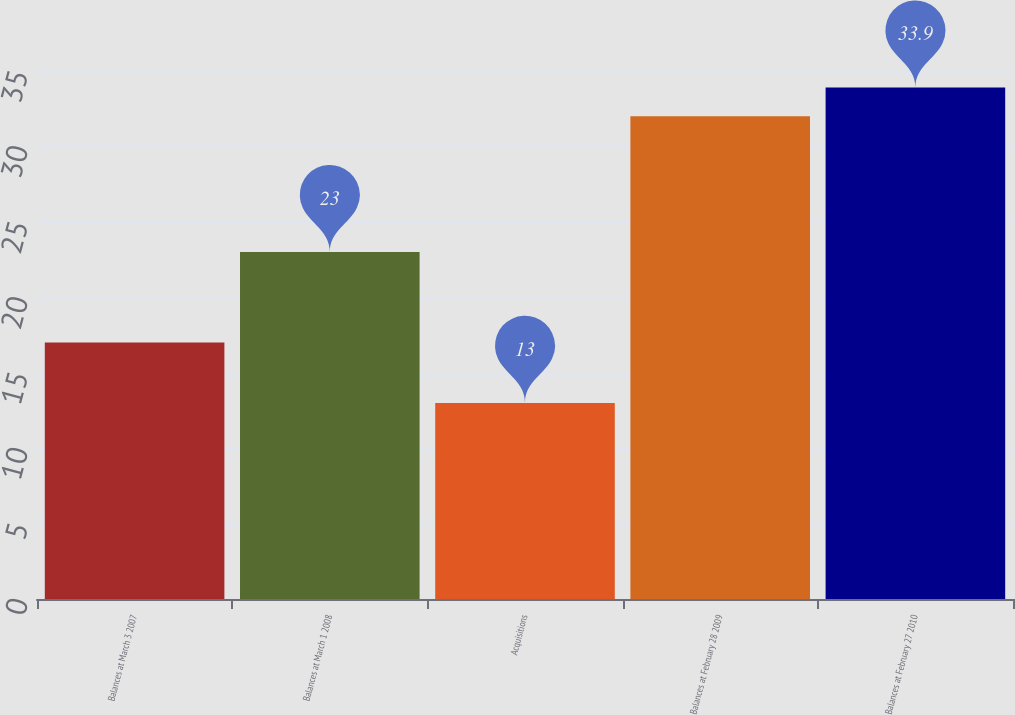Convert chart. <chart><loc_0><loc_0><loc_500><loc_500><bar_chart><fcel>Balances at March 3 2007<fcel>Balances at March 1 2008<fcel>Acquisitions<fcel>Balances at February 28 2009<fcel>Balances at February 27 2010<nl><fcel>17<fcel>23<fcel>13<fcel>32<fcel>33.9<nl></chart> 